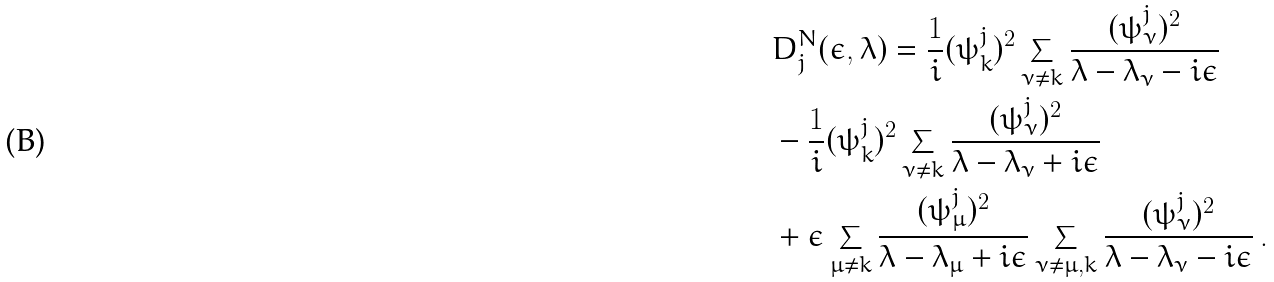Convert formula to latex. <formula><loc_0><loc_0><loc_500><loc_500>& D ^ { N } _ { j } ( \epsilon , \lambda ) = \frac { 1 } { i } ( \psi _ { k } ^ { j } ) ^ { 2 } \sum _ { \nu \neq k } \frac { ( \psi _ { \nu } ^ { j } ) ^ { 2 } } { \lambda - \lambda _ { \nu } - i \epsilon } \\ & - \frac { 1 } { i } ( \psi _ { k } ^ { j } ) ^ { 2 } \sum _ { \nu \neq k } \frac { ( \psi _ { \nu } ^ { j } ) ^ { 2 } } { \lambda - \lambda _ { \nu } + i \epsilon } \\ & + \epsilon \sum _ { \mu \neq k } \frac { ( \psi _ { \mu } ^ { j } ) ^ { 2 } } { \lambda - \lambda _ { \mu } + i \epsilon } \sum _ { \nu \neq \mu , k } \frac { ( \psi _ { \nu } ^ { j } ) ^ { 2 } } { \lambda - \lambda _ { \nu } - i \epsilon } \, .</formula> 